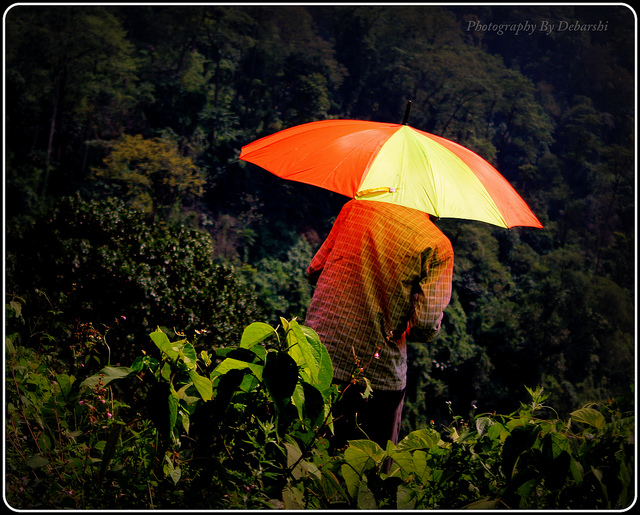Extract all visible text content from this image. Photography By Debarshi 